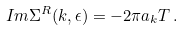<formula> <loc_0><loc_0><loc_500><loc_500>I m \Sigma ^ { R } ( k , \epsilon ) = - 2 \pi a _ { k } T \, .</formula> 